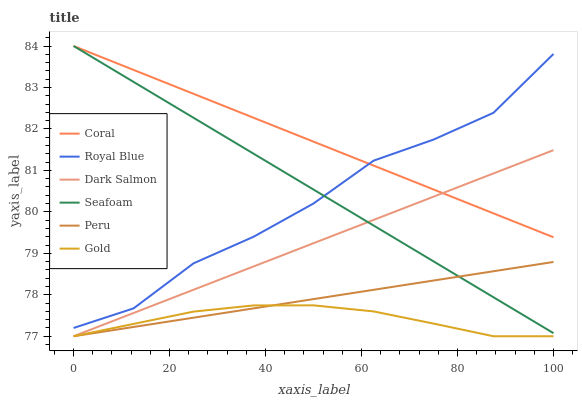Does Gold have the minimum area under the curve?
Answer yes or no. Yes. Does Coral have the maximum area under the curve?
Answer yes or no. Yes. Does Dark Salmon have the minimum area under the curve?
Answer yes or no. No. Does Dark Salmon have the maximum area under the curve?
Answer yes or no. No. Is Dark Salmon the smoothest?
Answer yes or no. Yes. Is Royal Blue the roughest?
Answer yes or no. Yes. Is Coral the smoothest?
Answer yes or no. No. Is Coral the roughest?
Answer yes or no. No. Does Coral have the lowest value?
Answer yes or no. No. Does Seafoam have the highest value?
Answer yes or no. Yes. Does Dark Salmon have the highest value?
Answer yes or no. No. Is Gold less than Royal Blue?
Answer yes or no. Yes. Is Seafoam greater than Gold?
Answer yes or no. Yes. Does Dark Salmon intersect Seafoam?
Answer yes or no. Yes. Is Dark Salmon less than Seafoam?
Answer yes or no. No. Is Dark Salmon greater than Seafoam?
Answer yes or no. No. Does Gold intersect Royal Blue?
Answer yes or no. No. 